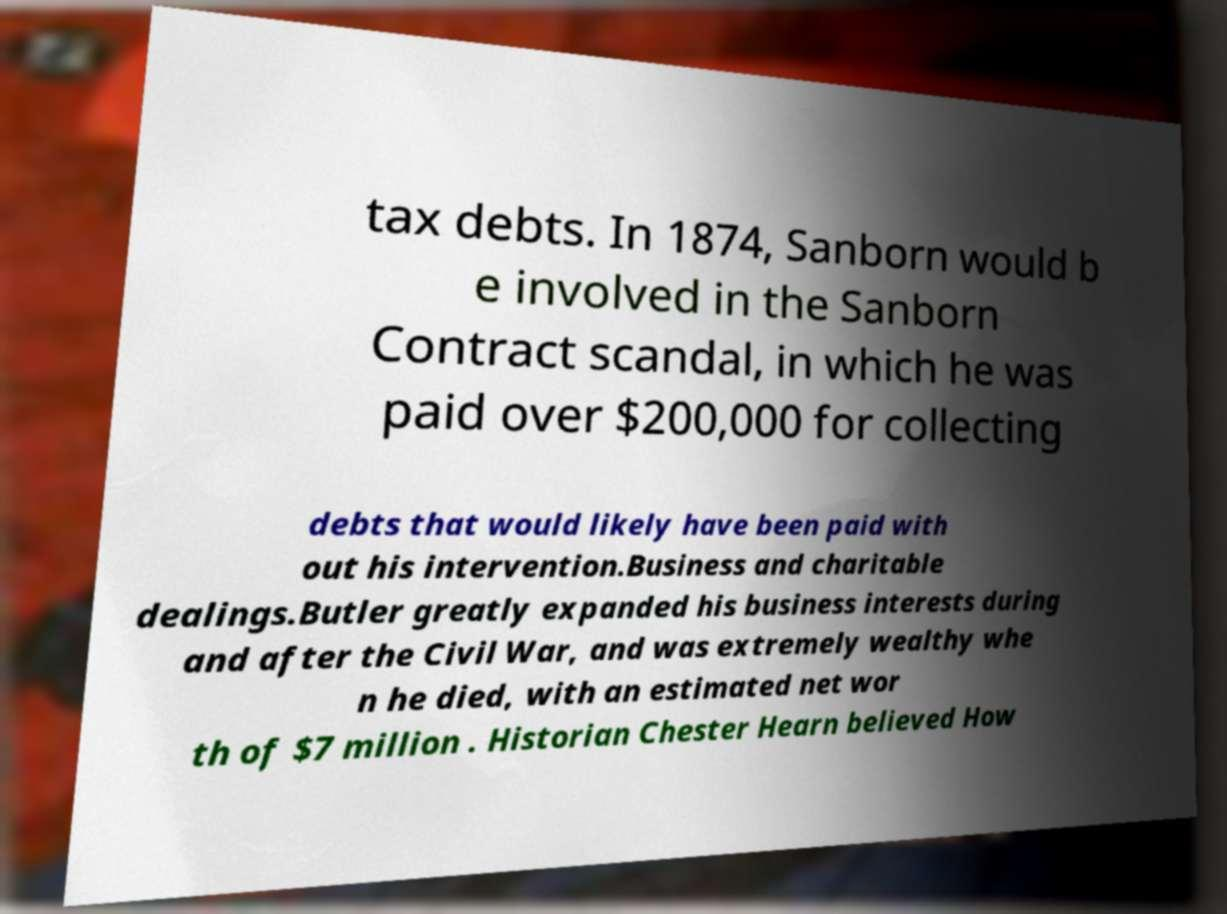Please identify and transcribe the text found in this image. tax debts. In 1874, Sanborn would b e involved in the Sanborn Contract scandal, in which he was paid over $200,000 for collecting debts that would likely have been paid with out his intervention.Business and charitable dealings.Butler greatly expanded his business interests during and after the Civil War, and was extremely wealthy whe n he died, with an estimated net wor th of $7 million . Historian Chester Hearn believed How 